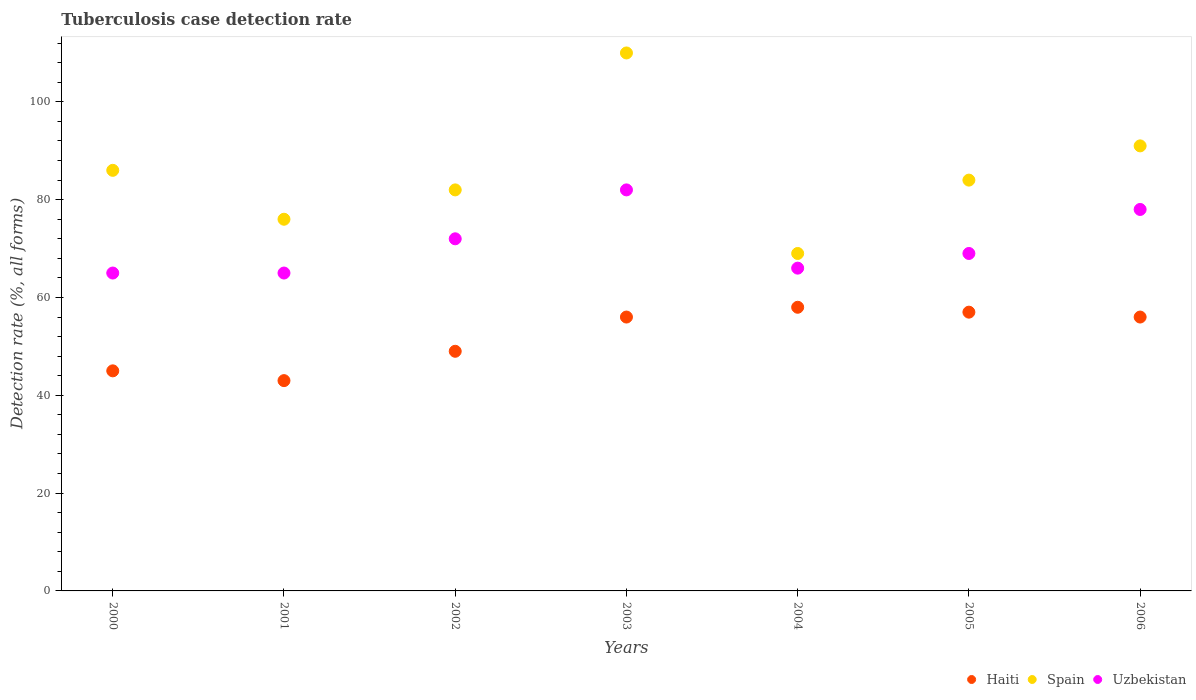Is the number of dotlines equal to the number of legend labels?
Make the answer very short. Yes. Across all years, what is the maximum tuberculosis case detection rate in in Uzbekistan?
Your answer should be compact. 82. In which year was the tuberculosis case detection rate in in Haiti maximum?
Ensure brevity in your answer.  2004. What is the total tuberculosis case detection rate in in Uzbekistan in the graph?
Ensure brevity in your answer.  497. What is the difference between the tuberculosis case detection rate in in Haiti in 2002 and that in 2005?
Ensure brevity in your answer.  -8. What is the difference between the tuberculosis case detection rate in in Haiti in 2004 and the tuberculosis case detection rate in in Uzbekistan in 2002?
Offer a very short reply. -14. In the year 2000, what is the difference between the tuberculosis case detection rate in in Haiti and tuberculosis case detection rate in in Spain?
Offer a terse response. -41. In how many years, is the tuberculosis case detection rate in in Spain greater than 52 %?
Ensure brevity in your answer.  7. What is the ratio of the tuberculosis case detection rate in in Uzbekistan in 2005 to that in 2006?
Offer a very short reply. 0.88. What is the difference between the highest and the second highest tuberculosis case detection rate in in Spain?
Provide a succinct answer. 19. What is the difference between the highest and the lowest tuberculosis case detection rate in in Spain?
Make the answer very short. 41. In how many years, is the tuberculosis case detection rate in in Haiti greater than the average tuberculosis case detection rate in in Haiti taken over all years?
Keep it short and to the point. 4. Is it the case that in every year, the sum of the tuberculosis case detection rate in in Spain and tuberculosis case detection rate in in Haiti  is greater than the tuberculosis case detection rate in in Uzbekistan?
Your answer should be compact. Yes. Does the graph contain grids?
Keep it short and to the point. No. How are the legend labels stacked?
Your answer should be very brief. Horizontal. What is the title of the graph?
Your answer should be compact. Tuberculosis case detection rate. What is the label or title of the X-axis?
Give a very brief answer. Years. What is the label or title of the Y-axis?
Your response must be concise. Detection rate (%, all forms). What is the Detection rate (%, all forms) in Haiti in 2000?
Provide a short and direct response. 45. What is the Detection rate (%, all forms) in Spain in 2000?
Provide a short and direct response. 86. What is the Detection rate (%, all forms) of Uzbekistan in 2000?
Give a very brief answer. 65. What is the Detection rate (%, all forms) in Spain in 2001?
Offer a terse response. 76. What is the Detection rate (%, all forms) of Haiti in 2002?
Keep it short and to the point. 49. What is the Detection rate (%, all forms) in Uzbekistan in 2002?
Your answer should be very brief. 72. What is the Detection rate (%, all forms) in Spain in 2003?
Offer a very short reply. 110. What is the Detection rate (%, all forms) in Haiti in 2004?
Provide a short and direct response. 58. What is the Detection rate (%, all forms) of Spain in 2004?
Offer a terse response. 69. What is the Detection rate (%, all forms) of Haiti in 2005?
Ensure brevity in your answer.  57. What is the Detection rate (%, all forms) of Haiti in 2006?
Keep it short and to the point. 56. What is the Detection rate (%, all forms) of Spain in 2006?
Make the answer very short. 91. Across all years, what is the maximum Detection rate (%, all forms) of Spain?
Provide a short and direct response. 110. Across all years, what is the maximum Detection rate (%, all forms) in Uzbekistan?
Make the answer very short. 82. Across all years, what is the minimum Detection rate (%, all forms) in Haiti?
Your response must be concise. 43. Across all years, what is the minimum Detection rate (%, all forms) of Uzbekistan?
Offer a very short reply. 65. What is the total Detection rate (%, all forms) in Haiti in the graph?
Offer a very short reply. 364. What is the total Detection rate (%, all forms) in Spain in the graph?
Offer a very short reply. 598. What is the total Detection rate (%, all forms) of Uzbekistan in the graph?
Offer a very short reply. 497. What is the difference between the Detection rate (%, all forms) of Spain in 2000 and that in 2001?
Give a very brief answer. 10. What is the difference between the Detection rate (%, all forms) of Haiti in 2000 and that in 2002?
Offer a terse response. -4. What is the difference between the Detection rate (%, all forms) in Uzbekistan in 2000 and that in 2002?
Give a very brief answer. -7. What is the difference between the Detection rate (%, all forms) in Spain in 2000 and that in 2003?
Make the answer very short. -24. What is the difference between the Detection rate (%, all forms) in Uzbekistan in 2000 and that in 2003?
Make the answer very short. -17. What is the difference between the Detection rate (%, all forms) in Haiti in 2000 and that in 2005?
Make the answer very short. -12. What is the difference between the Detection rate (%, all forms) of Spain in 2000 and that in 2005?
Your answer should be compact. 2. What is the difference between the Detection rate (%, all forms) in Spain in 2000 and that in 2006?
Make the answer very short. -5. What is the difference between the Detection rate (%, all forms) in Uzbekistan in 2000 and that in 2006?
Keep it short and to the point. -13. What is the difference between the Detection rate (%, all forms) of Spain in 2001 and that in 2002?
Offer a very short reply. -6. What is the difference between the Detection rate (%, all forms) of Uzbekistan in 2001 and that in 2002?
Keep it short and to the point. -7. What is the difference between the Detection rate (%, all forms) of Haiti in 2001 and that in 2003?
Ensure brevity in your answer.  -13. What is the difference between the Detection rate (%, all forms) of Spain in 2001 and that in 2003?
Your response must be concise. -34. What is the difference between the Detection rate (%, all forms) in Haiti in 2001 and that in 2004?
Your answer should be compact. -15. What is the difference between the Detection rate (%, all forms) of Uzbekistan in 2001 and that in 2004?
Your answer should be compact. -1. What is the difference between the Detection rate (%, all forms) in Spain in 2001 and that in 2005?
Offer a terse response. -8. What is the difference between the Detection rate (%, all forms) of Haiti in 2001 and that in 2006?
Offer a very short reply. -13. What is the difference between the Detection rate (%, all forms) of Spain in 2001 and that in 2006?
Offer a very short reply. -15. What is the difference between the Detection rate (%, all forms) of Uzbekistan in 2001 and that in 2006?
Offer a very short reply. -13. What is the difference between the Detection rate (%, all forms) of Spain in 2002 and that in 2003?
Make the answer very short. -28. What is the difference between the Detection rate (%, all forms) of Uzbekistan in 2002 and that in 2003?
Offer a terse response. -10. What is the difference between the Detection rate (%, all forms) in Spain in 2002 and that in 2004?
Provide a short and direct response. 13. What is the difference between the Detection rate (%, all forms) in Spain in 2002 and that in 2005?
Provide a short and direct response. -2. What is the difference between the Detection rate (%, all forms) in Uzbekistan in 2002 and that in 2005?
Your response must be concise. 3. What is the difference between the Detection rate (%, all forms) of Haiti in 2002 and that in 2006?
Provide a succinct answer. -7. What is the difference between the Detection rate (%, all forms) of Spain in 2002 and that in 2006?
Provide a short and direct response. -9. What is the difference between the Detection rate (%, all forms) in Uzbekistan in 2002 and that in 2006?
Provide a succinct answer. -6. What is the difference between the Detection rate (%, all forms) of Haiti in 2003 and that in 2004?
Make the answer very short. -2. What is the difference between the Detection rate (%, all forms) in Spain in 2003 and that in 2004?
Give a very brief answer. 41. What is the difference between the Detection rate (%, all forms) in Uzbekistan in 2003 and that in 2004?
Provide a short and direct response. 16. What is the difference between the Detection rate (%, all forms) in Haiti in 2003 and that in 2005?
Ensure brevity in your answer.  -1. What is the difference between the Detection rate (%, all forms) of Spain in 2003 and that in 2005?
Provide a short and direct response. 26. What is the difference between the Detection rate (%, all forms) in Haiti in 2003 and that in 2006?
Your answer should be compact. 0. What is the difference between the Detection rate (%, all forms) in Spain in 2003 and that in 2006?
Give a very brief answer. 19. What is the difference between the Detection rate (%, all forms) in Haiti in 2004 and that in 2005?
Provide a succinct answer. 1. What is the difference between the Detection rate (%, all forms) of Spain in 2004 and that in 2005?
Provide a short and direct response. -15. What is the difference between the Detection rate (%, all forms) in Uzbekistan in 2004 and that in 2006?
Provide a succinct answer. -12. What is the difference between the Detection rate (%, all forms) in Haiti in 2000 and the Detection rate (%, all forms) in Spain in 2001?
Offer a terse response. -31. What is the difference between the Detection rate (%, all forms) of Haiti in 2000 and the Detection rate (%, all forms) of Uzbekistan in 2001?
Your answer should be very brief. -20. What is the difference between the Detection rate (%, all forms) of Spain in 2000 and the Detection rate (%, all forms) of Uzbekistan in 2001?
Your answer should be compact. 21. What is the difference between the Detection rate (%, all forms) in Haiti in 2000 and the Detection rate (%, all forms) in Spain in 2002?
Offer a terse response. -37. What is the difference between the Detection rate (%, all forms) of Spain in 2000 and the Detection rate (%, all forms) of Uzbekistan in 2002?
Ensure brevity in your answer.  14. What is the difference between the Detection rate (%, all forms) in Haiti in 2000 and the Detection rate (%, all forms) in Spain in 2003?
Offer a very short reply. -65. What is the difference between the Detection rate (%, all forms) in Haiti in 2000 and the Detection rate (%, all forms) in Uzbekistan in 2003?
Ensure brevity in your answer.  -37. What is the difference between the Detection rate (%, all forms) in Spain in 2000 and the Detection rate (%, all forms) in Uzbekistan in 2004?
Your answer should be compact. 20. What is the difference between the Detection rate (%, all forms) in Haiti in 2000 and the Detection rate (%, all forms) in Spain in 2005?
Your response must be concise. -39. What is the difference between the Detection rate (%, all forms) of Haiti in 2000 and the Detection rate (%, all forms) of Uzbekistan in 2005?
Your response must be concise. -24. What is the difference between the Detection rate (%, all forms) of Spain in 2000 and the Detection rate (%, all forms) of Uzbekistan in 2005?
Ensure brevity in your answer.  17. What is the difference between the Detection rate (%, all forms) of Haiti in 2000 and the Detection rate (%, all forms) of Spain in 2006?
Your response must be concise. -46. What is the difference between the Detection rate (%, all forms) in Haiti in 2000 and the Detection rate (%, all forms) in Uzbekistan in 2006?
Offer a very short reply. -33. What is the difference between the Detection rate (%, all forms) in Spain in 2000 and the Detection rate (%, all forms) in Uzbekistan in 2006?
Provide a succinct answer. 8. What is the difference between the Detection rate (%, all forms) in Haiti in 2001 and the Detection rate (%, all forms) in Spain in 2002?
Keep it short and to the point. -39. What is the difference between the Detection rate (%, all forms) in Haiti in 2001 and the Detection rate (%, all forms) in Spain in 2003?
Provide a short and direct response. -67. What is the difference between the Detection rate (%, all forms) of Haiti in 2001 and the Detection rate (%, all forms) of Uzbekistan in 2003?
Provide a short and direct response. -39. What is the difference between the Detection rate (%, all forms) in Spain in 2001 and the Detection rate (%, all forms) in Uzbekistan in 2003?
Offer a very short reply. -6. What is the difference between the Detection rate (%, all forms) of Haiti in 2001 and the Detection rate (%, all forms) of Uzbekistan in 2004?
Ensure brevity in your answer.  -23. What is the difference between the Detection rate (%, all forms) in Spain in 2001 and the Detection rate (%, all forms) in Uzbekistan in 2004?
Make the answer very short. 10. What is the difference between the Detection rate (%, all forms) in Haiti in 2001 and the Detection rate (%, all forms) in Spain in 2005?
Provide a succinct answer. -41. What is the difference between the Detection rate (%, all forms) of Haiti in 2001 and the Detection rate (%, all forms) of Uzbekistan in 2005?
Your response must be concise. -26. What is the difference between the Detection rate (%, all forms) in Haiti in 2001 and the Detection rate (%, all forms) in Spain in 2006?
Your answer should be very brief. -48. What is the difference between the Detection rate (%, all forms) in Haiti in 2001 and the Detection rate (%, all forms) in Uzbekistan in 2006?
Provide a short and direct response. -35. What is the difference between the Detection rate (%, all forms) in Haiti in 2002 and the Detection rate (%, all forms) in Spain in 2003?
Ensure brevity in your answer.  -61. What is the difference between the Detection rate (%, all forms) in Haiti in 2002 and the Detection rate (%, all forms) in Uzbekistan in 2003?
Your response must be concise. -33. What is the difference between the Detection rate (%, all forms) in Spain in 2002 and the Detection rate (%, all forms) in Uzbekistan in 2003?
Make the answer very short. 0. What is the difference between the Detection rate (%, all forms) in Haiti in 2002 and the Detection rate (%, all forms) in Spain in 2004?
Make the answer very short. -20. What is the difference between the Detection rate (%, all forms) of Haiti in 2002 and the Detection rate (%, all forms) of Uzbekistan in 2004?
Give a very brief answer. -17. What is the difference between the Detection rate (%, all forms) in Spain in 2002 and the Detection rate (%, all forms) in Uzbekistan in 2004?
Provide a succinct answer. 16. What is the difference between the Detection rate (%, all forms) in Haiti in 2002 and the Detection rate (%, all forms) in Spain in 2005?
Your answer should be compact. -35. What is the difference between the Detection rate (%, all forms) in Haiti in 2002 and the Detection rate (%, all forms) in Spain in 2006?
Your answer should be very brief. -42. What is the difference between the Detection rate (%, all forms) of Spain in 2002 and the Detection rate (%, all forms) of Uzbekistan in 2006?
Your answer should be compact. 4. What is the difference between the Detection rate (%, all forms) of Haiti in 2003 and the Detection rate (%, all forms) of Spain in 2004?
Your answer should be compact. -13. What is the difference between the Detection rate (%, all forms) in Haiti in 2003 and the Detection rate (%, all forms) in Uzbekistan in 2004?
Offer a very short reply. -10. What is the difference between the Detection rate (%, all forms) of Spain in 2003 and the Detection rate (%, all forms) of Uzbekistan in 2004?
Keep it short and to the point. 44. What is the difference between the Detection rate (%, all forms) of Haiti in 2003 and the Detection rate (%, all forms) of Spain in 2005?
Offer a terse response. -28. What is the difference between the Detection rate (%, all forms) in Spain in 2003 and the Detection rate (%, all forms) in Uzbekistan in 2005?
Provide a succinct answer. 41. What is the difference between the Detection rate (%, all forms) of Haiti in 2003 and the Detection rate (%, all forms) of Spain in 2006?
Offer a terse response. -35. What is the difference between the Detection rate (%, all forms) of Haiti in 2004 and the Detection rate (%, all forms) of Uzbekistan in 2005?
Offer a very short reply. -11. What is the difference between the Detection rate (%, all forms) of Spain in 2004 and the Detection rate (%, all forms) of Uzbekistan in 2005?
Ensure brevity in your answer.  0. What is the difference between the Detection rate (%, all forms) of Haiti in 2004 and the Detection rate (%, all forms) of Spain in 2006?
Offer a very short reply. -33. What is the difference between the Detection rate (%, all forms) in Spain in 2004 and the Detection rate (%, all forms) in Uzbekistan in 2006?
Provide a short and direct response. -9. What is the difference between the Detection rate (%, all forms) in Haiti in 2005 and the Detection rate (%, all forms) in Spain in 2006?
Make the answer very short. -34. What is the difference between the Detection rate (%, all forms) of Haiti in 2005 and the Detection rate (%, all forms) of Uzbekistan in 2006?
Your answer should be compact. -21. What is the difference between the Detection rate (%, all forms) of Spain in 2005 and the Detection rate (%, all forms) of Uzbekistan in 2006?
Your response must be concise. 6. What is the average Detection rate (%, all forms) of Spain per year?
Provide a succinct answer. 85.43. What is the average Detection rate (%, all forms) in Uzbekistan per year?
Your answer should be very brief. 71. In the year 2000, what is the difference between the Detection rate (%, all forms) of Haiti and Detection rate (%, all forms) of Spain?
Your answer should be very brief. -41. In the year 2000, what is the difference between the Detection rate (%, all forms) in Spain and Detection rate (%, all forms) in Uzbekistan?
Make the answer very short. 21. In the year 2001, what is the difference between the Detection rate (%, all forms) in Haiti and Detection rate (%, all forms) in Spain?
Your answer should be compact. -33. In the year 2001, what is the difference between the Detection rate (%, all forms) of Haiti and Detection rate (%, all forms) of Uzbekistan?
Your answer should be very brief. -22. In the year 2001, what is the difference between the Detection rate (%, all forms) in Spain and Detection rate (%, all forms) in Uzbekistan?
Provide a short and direct response. 11. In the year 2002, what is the difference between the Detection rate (%, all forms) of Haiti and Detection rate (%, all forms) of Spain?
Give a very brief answer. -33. In the year 2002, what is the difference between the Detection rate (%, all forms) in Haiti and Detection rate (%, all forms) in Uzbekistan?
Your response must be concise. -23. In the year 2002, what is the difference between the Detection rate (%, all forms) in Spain and Detection rate (%, all forms) in Uzbekistan?
Keep it short and to the point. 10. In the year 2003, what is the difference between the Detection rate (%, all forms) in Haiti and Detection rate (%, all forms) in Spain?
Your answer should be very brief. -54. In the year 2003, what is the difference between the Detection rate (%, all forms) of Haiti and Detection rate (%, all forms) of Uzbekistan?
Provide a succinct answer. -26. In the year 2004, what is the difference between the Detection rate (%, all forms) of Haiti and Detection rate (%, all forms) of Spain?
Offer a very short reply. -11. In the year 2004, what is the difference between the Detection rate (%, all forms) of Haiti and Detection rate (%, all forms) of Uzbekistan?
Your answer should be very brief. -8. In the year 2004, what is the difference between the Detection rate (%, all forms) in Spain and Detection rate (%, all forms) in Uzbekistan?
Offer a terse response. 3. In the year 2005, what is the difference between the Detection rate (%, all forms) in Haiti and Detection rate (%, all forms) in Uzbekistan?
Provide a short and direct response. -12. In the year 2006, what is the difference between the Detection rate (%, all forms) of Haiti and Detection rate (%, all forms) of Spain?
Provide a short and direct response. -35. What is the ratio of the Detection rate (%, all forms) in Haiti in 2000 to that in 2001?
Offer a terse response. 1.05. What is the ratio of the Detection rate (%, all forms) of Spain in 2000 to that in 2001?
Your response must be concise. 1.13. What is the ratio of the Detection rate (%, all forms) in Haiti in 2000 to that in 2002?
Your answer should be very brief. 0.92. What is the ratio of the Detection rate (%, all forms) in Spain in 2000 to that in 2002?
Ensure brevity in your answer.  1.05. What is the ratio of the Detection rate (%, all forms) of Uzbekistan in 2000 to that in 2002?
Your answer should be compact. 0.9. What is the ratio of the Detection rate (%, all forms) of Haiti in 2000 to that in 2003?
Your answer should be compact. 0.8. What is the ratio of the Detection rate (%, all forms) in Spain in 2000 to that in 2003?
Your answer should be compact. 0.78. What is the ratio of the Detection rate (%, all forms) in Uzbekistan in 2000 to that in 2003?
Your response must be concise. 0.79. What is the ratio of the Detection rate (%, all forms) of Haiti in 2000 to that in 2004?
Your answer should be compact. 0.78. What is the ratio of the Detection rate (%, all forms) in Spain in 2000 to that in 2004?
Offer a very short reply. 1.25. What is the ratio of the Detection rate (%, all forms) of Haiti in 2000 to that in 2005?
Give a very brief answer. 0.79. What is the ratio of the Detection rate (%, all forms) of Spain in 2000 to that in 2005?
Offer a very short reply. 1.02. What is the ratio of the Detection rate (%, all forms) in Uzbekistan in 2000 to that in 2005?
Provide a short and direct response. 0.94. What is the ratio of the Detection rate (%, all forms) in Haiti in 2000 to that in 2006?
Offer a terse response. 0.8. What is the ratio of the Detection rate (%, all forms) of Spain in 2000 to that in 2006?
Your answer should be very brief. 0.95. What is the ratio of the Detection rate (%, all forms) in Haiti in 2001 to that in 2002?
Offer a terse response. 0.88. What is the ratio of the Detection rate (%, all forms) of Spain in 2001 to that in 2002?
Offer a very short reply. 0.93. What is the ratio of the Detection rate (%, all forms) in Uzbekistan in 2001 to that in 2002?
Provide a short and direct response. 0.9. What is the ratio of the Detection rate (%, all forms) of Haiti in 2001 to that in 2003?
Provide a short and direct response. 0.77. What is the ratio of the Detection rate (%, all forms) in Spain in 2001 to that in 2003?
Make the answer very short. 0.69. What is the ratio of the Detection rate (%, all forms) of Uzbekistan in 2001 to that in 2003?
Give a very brief answer. 0.79. What is the ratio of the Detection rate (%, all forms) in Haiti in 2001 to that in 2004?
Ensure brevity in your answer.  0.74. What is the ratio of the Detection rate (%, all forms) of Spain in 2001 to that in 2004?
Your answer should be compact. 1.1. What is the ratio of the Detection rate (%, all forms) of Uzbekistan in 2001 to that in 2004?
Offer a terse response. 0.98. What is the ratio of the Detection rate (%, all forms) of Haiti in 2001 to that in 2005?
Make the answer very short. 0.75. What is the ratio of the Detection rate (%, all forms) in Spain in 2001 to that in 2005?
Provide a short and direct response. 0.9. What is the ratio of the Detection rate (%, all forms) of Uzbekistan in 2001 to that in 2005?
Ensure brevity in your answer.  0.94. What is the ratio of the Detection rate (%, all forms) of Haiti in 2001 to that in 2006?
Make the answer very short. 0.77. What is the ratio of the Detection rate (%, all forms) in Spain in 2001 to that in 2006?
Your response must be concise. 0.84. What is the ratio of the Detection rate (%, all forms) in Spain in 2002 to that in 2003?
Offer a terse response. 0.75. What is the ratio of the Detection rate (%, all forms) in Uzbekistan in 2002 to that in 2003?
Make the answer very short. 0.88. What is the ratio of the Detection rate (%, all forms) in Haiti in 2002 to that in 2004?
Give a very brief answer. 0.84. What is the ratio of the Detection rate (%, all forms) in Spain in 2002 to that in 2004?
Provide a succinct answer. 1.19. What is the ratio of the Detection rate (%, all forms) of Haiti in 2002 to that in 2005?
Provide a short and direct response. 0.86. What is the ratio of the Detection rate (%, all forms) in Spain in 2002 to that in 2005?
Provide a short and direct response. 0.98. What is the ratio of the Detection rate (%, all forms) in Uzbekistan in 2002 to that in 2005?
Your answer should be compact. 1.04. What is the ratio of the Detection rate (%, all forms) of Spain in 2002 to that in 2006?
Offer a very short reply. 0.9. What is the ratio of the Detection rate (%, all forms) of Haiti in 2003 to that in 2004?
Give a very brief answer. 0.97. What is the ratio of the Detection rate (%, all forms) in Spain in 2003 to that in 2004?
Provide a short and direct response. 1.59. What is the ratio of the Detection rate (%, all forms) of Uzbekistan in 2003 to that in 2004?
Ensure brevity in your answer.  1.24. What is the ratio of the Detection rate (%, all forms) of Haiti in 2003 to that in 2005?
Your response must be concise. 0.98. What is the ratio of the Detection rate (%, all forms) of Spain in 2003 to that in 2005?
Your response must be concise. 1.31. What is the ratio of the Detection rate (%, all forms) of Uzbekistan in 2003 to that in 2005?
Give a very brief answer. 1.19. What is the ratio of the Detection rate (%, all forms) of Spain in 2003 to that in 2006?
Provide a short and direct response. 1.21. What is the ratio of the Detection rate (%, all forms) in Uzbekistan in 2003 to that in 2006?
Provide a short and direct response. 1.05. What is the ratio of the Detection rate (%, all forms) in Haiti in 2004 to that in 2005?
Provide a succinct answer. 1.02. What is the ratio of the Detection rate (%, all forms) of Spain in 2004 to that in 2005?
Keep it short and to the point. 0.82. What is the ratio of the Detection rate (%, all forms) in Uzbekistan in 2004 to that in 2005?
Offer a very short reply. 0.96. What is the ratio of the Detection rate (%, all forms) of Haiti in 2004 to that in 2006?
Offer a very short reply. 1.04. What is the ratio of the Detection rate (%, all forms) of Spain in 2004 to that in 2006?
Keep it short and to the point. 0.76. What is the ratio of the Detection rate (%, all forms) in Uzbekistan in 2004 to that in 2006?
Offer a terse response. 0.85. What is the ratio of the Detection rate (%, all forms) of Haiti in 2005 to that in 2006?
Provide a succinct answer. 1.02. What is the ratio of the Detection rate (%, all forms) of Uzbekistan in 2005 to that in 2006?
Ensure brevity in your answer.  0.88. What is the difference between the highest and the second highest Detection rate (%, all forms) of Haiti?
Your response must be concise. 1. 